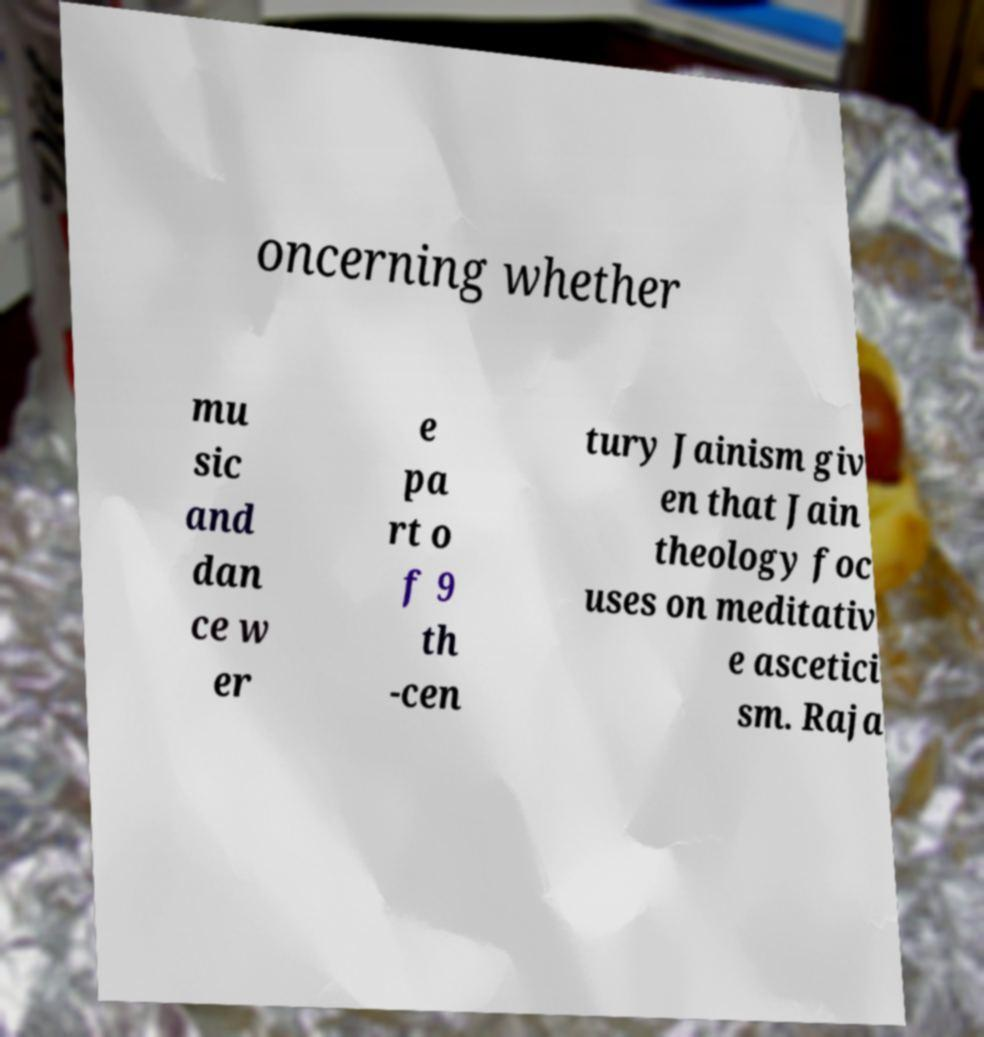I need the written content from this picture converted into text. Can you do that? oncerning whether mu sic and dan ce w er e pa rt o f 9 th -cen tury Jainism giv en that Jain theology foc uses on meditativ e ascetici sm. Raja 